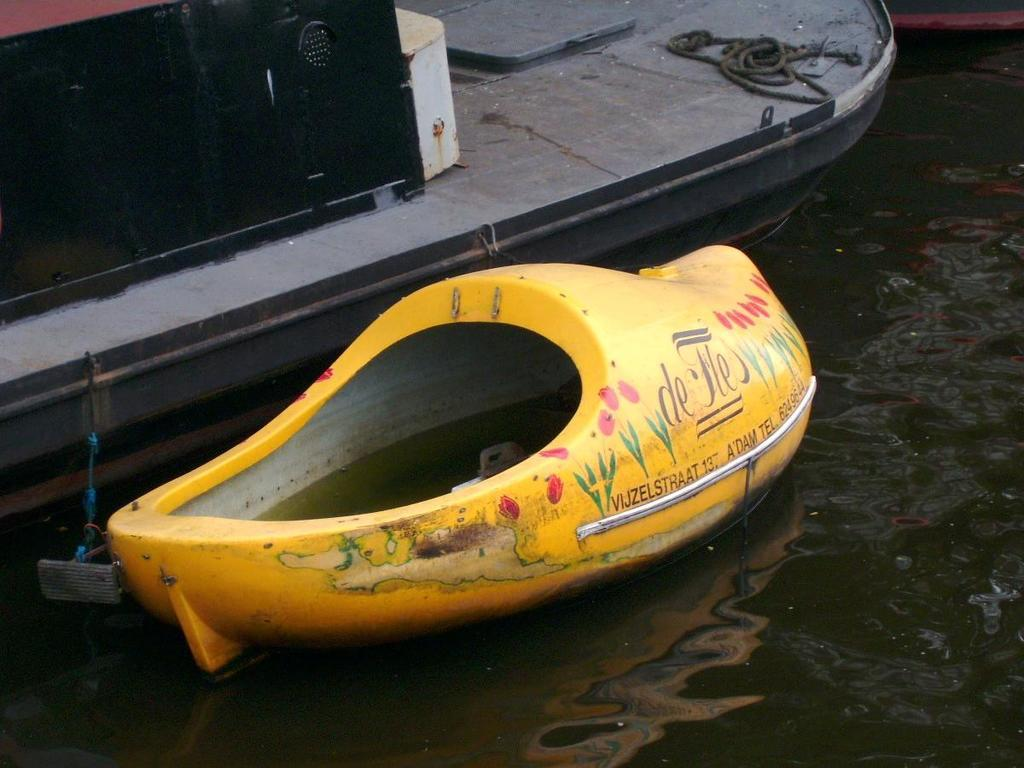What type of boat can be seen in the water in the image? There is a small yellow color boat in the water. Can you describe another boat in the image? There is a big boat in the water. What feature is present on the big boat? The big boat has a rope on it. What type of disease is affecting the canvas in the image? There is no canvas present in the image, and therefore no disease can be affecting it. 